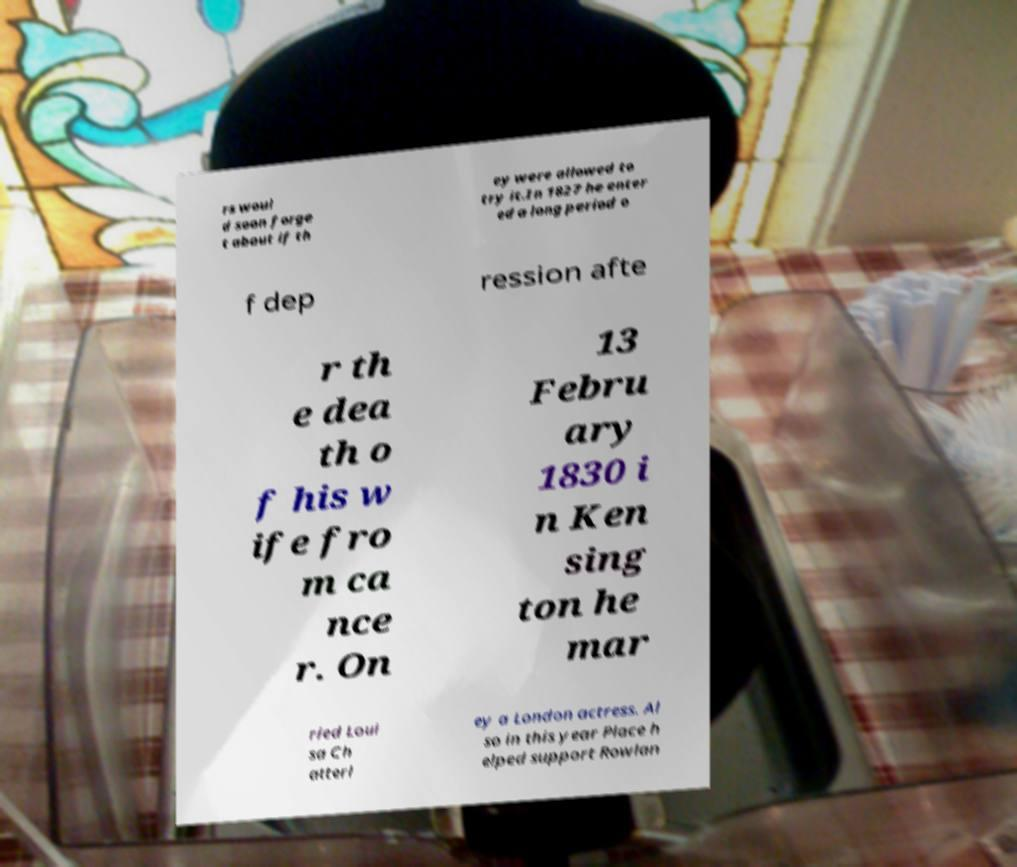For documentation purposes, I need the text within this image transcribed. Could you provide that? rs woul d soon forge t about if th ey were allowed to try it.In 1827 he enter ed a long period o f dep ression afte r th e dea th o f his w ife fro m ca nce r. On 13 Febru ary 1830 i n Ken sing ton he mar ried Loui sa Ch atterl ey a London actress. Al so in this year Place h elped support Rowlan 